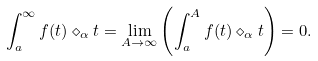Convert formula to latex. <formula><loc_0><loc_0><loc_500><loc_500>\int _ { a } ^ { \infty } f ( t ) \diamond _ { \alpha } t = \lim _ { A \rightarrow \infty } \left ( \int _ { a } ^ { A } f ( t ) \diamond _ { \alpha } t \right ) = 0 .</formula> 